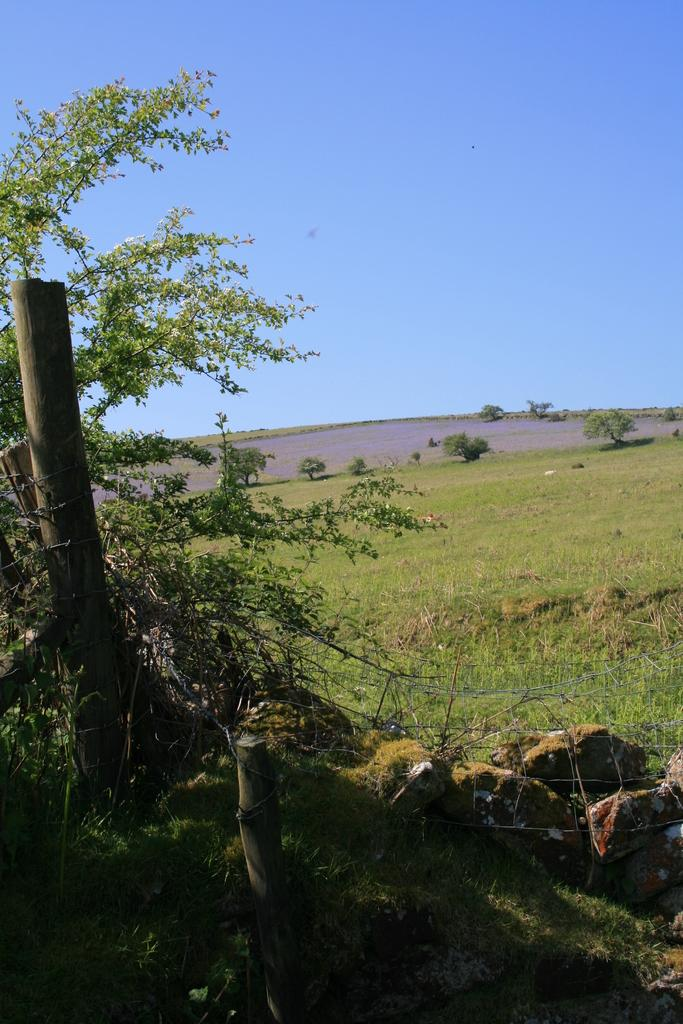What type of vegetation can be seen in the image? There are trees in the image. What type of structure is present in the image? There is a fence in the image. What type of terrain is visible in the image? There are rocks and grass in the image. What is visible in the background of the image? The sky is visible in the image. What type of rhythm can be heard in the image? There is no sound or rhythm present in the image, as it is a still photograph. What type of seat is visible in the image? There is no seat present in the image; it features trees, a fence, rocks, grass, and the sky. 